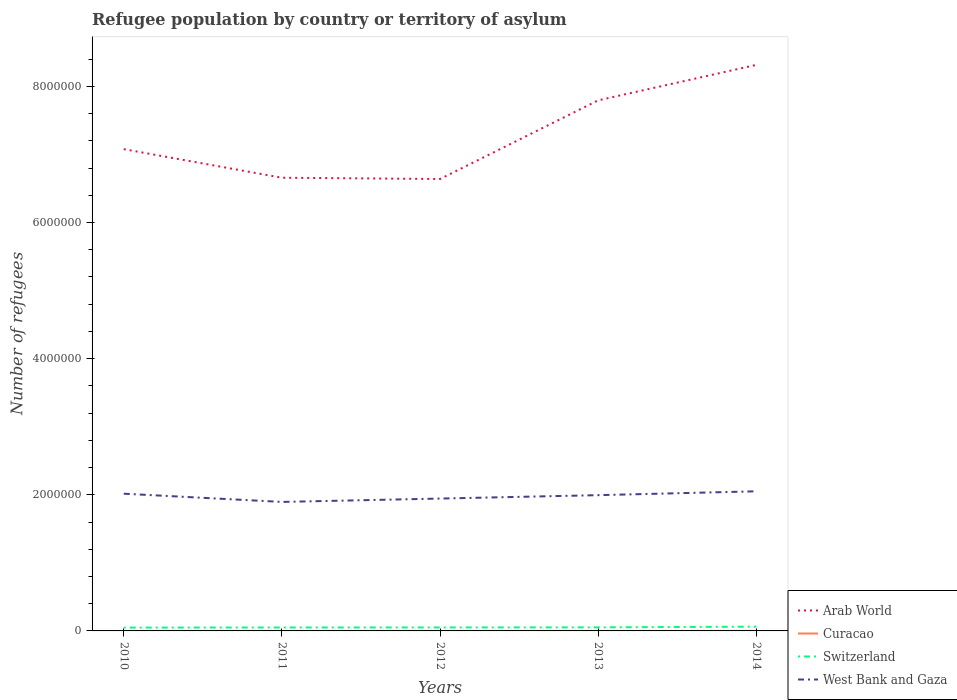How many different coloured lines are there?
Provide a short and direct response. 4. Does the line corresponding to Curacao intersect with the line corresponding to Arab World?
Your answer should be compact. No. Is the number of lines equal to the number of legend labels?
Offer a terse response. Yes. Across all years, what is the maximum number of refugees in Curacao?
Give a very brief answer. 6. What is the difference between the highest and the second highest number of refugees in West Bank and Gaza?
Provide a short and direct response. 1.56e+05. What is the difference between the highest and the lowest number of refugees in Switzerland?
Provide a succinct answer. 1. How many lines are there?
Give a very brief answer. 4. Does the graph contain any zero values?
Give a very brief answer. No. How many legend labels are there?
Your answer should be compact. 4. How are the legend labels stacked?
Ensure brevity in your answer.  Vertical. What is the title of the graph?
Offer a terse response. Refugee population by country or territory of asylum. Does "Turks and Caicos Islands" appear as one of the legend labels in the graph?
Give a very brief answer. No. What is the label or title of the Y-axis?
Ensure brevity in your answer.  Number of refugees. What is the Number of refugees in Arab World in 2010?
Make the answer very short. 7.08e+06. What is the Number of refugees of Switzerland in 2010?
Offer a terse response. 4.88e+04. What is the Number of refugees in West Bank and Gaza in 2010?
Offer a very short reply. 2.02e+06. What is the Number of refugees of Arab World in 2011?
Your response must be concise. 6.66e+06. What is the Number of refugees in Switzerland in 2011?
Keep it short and to the point. 5.04e+04. What is the Number of refugees in West Bank and Gaza in 2011?
Your answer should be very brief. 1.90e+06. What is the Number of refugees in Arab World in 2012?
Make the answer very short. 6.64e+06. What is the Number of refugees in Switzerland in 2012?
Offer a very short reply. 5.07e+04. What is the Number of refugees of West Bank and Gaza in 2012?
Offer a terse response. 1.94e+06. What is the Number of refugees of Arab World in 2013?
Provide a succinct answer. 7.79e+06. What is the Number of refugees in Switzerland in 2013?
Ensure brevity in your answer.  5.25e+04. What is the Number of refugees of West Bank and Gaza in 2013?
Keep it short and to the point. 1.99e+06. What is the Number of refugees in Arab World in 2014?
Offer a terse response. 8.32e+06. What is the Number of refugees in Curacao in 2014?
Provide a succinct answer. 37. What is the Number of refugees of Switzerland in 2014?
Your response must be concise. 6.26e+04. What is the Number of refugees of West Bank and Gaza in 2014?
Make the answer very short. 2.05e+06. Across all years, what is the maximum Number of refugees in Arab World?
Your answer should be very brief. 8.32e+06. Across all years, what is the maximum Number of refugees of Curacao?
Your answer should be compact. 37. Across all years, what is the maximum Number of refugees of Switzerland?
Keep it short and to the point. 6.26e+04. Across all years, what is the maximum Number of refugees in West Bank and Gaza?
Offer a terse response. 2.05e+06. Across all years, what is the minimum Number of refugees in Arab World?
Offer a terse response. 6.64e+06. Across all years, what is the minimum Number of refugees in Switzerland?
Give a very brief answer. 4.88e+04. Across all years, what is the minimum Number of refugees in West Bank and Gaza?
Provide a short and direct response. 1.90e+06. What is the total Number of refugees of Arab World in the graph?
Provide a short and direct response. 3.65e+07. What is the total Number of refugees in Curacao in the graph?
Your response must be concise. 79. What is the total Number of refugees in Switzerland in the graph?
Your response must be concise. 2.65e+05. What is the total Number of refugees in West Bank and Gaza in the graph?
Provide a short and direct response. 9.90e+06. What is the difference between the Number of refugees in Arab World in 2010 and that in 2011?
Your response must be concise. 4.20e+05. What is the difference between the Number of refugees of Switzerland in 2010 and that in 2011?
Your answer should be very brief. -1603. What is the difference between the Number of refugees in West Bank and Gaza in 2010 and that in 2011?
Make the answer very short. 1.21e+05. What is the difference between the Number of refugees in Arab World in 2010 and that in 2012?
Your answer should be very brief. 4.39e+05. What is the difference between the Number of refugees in Switzerland in 2010 and that in 2012?
Make the answer very short. -1934. What is the difference between the Number of refugees of West Bank and Gaza in 2010 and that in 2012?
Offer a very short reply. 7.13e+04. What is the difference between the Number of refugees in Arab World in 2010 and that in 2013?
Your response must be concise. -7.17e+05. What is the difference between the Number of refugees of Switzerland in 2010 and that in 2013?
Your answer should be compact. -3651. What is the difference between the Number of refugees in West Bank and Gaza in 2010 and that in 2013?
Make the answer very short. 2.14e+04. What is the difference between the Number of refugees in Arab World in 2010 and that in 2014?
Give a very brief answer. -1.24e+06. What is the difference between the Number of refugees in Switzerland in 2010 and that in 2014?
Your answer should be compact. -1.38e+04. What is the difference between the Number of refugees in West Bank and Gaza in 2010 and that in 2014?
Give a very brief answer. -3.52e+04. What is the difference between the Number of refugees in Arab World in 2011 and that in 2012?
Provide a succinct answer. 1.87e+04. What is the difference between the Number of refugees in Switzerland in 2011 and that in 2012?
Ensure brevity in your answer.  -331. What is the difference between the Number of refugees of West Bank and Gaza in 2011 and that in 2012?
Your answer should be very brief. -4.95e+04. What is the difference between the Number of refugees of Arab World in 2011 and that in 2013?
Keep it short and to the point. -1.14e+06. What is the difference between the Number of refugees of Switzerland in 2011 and that in 2013?
Offer a very short reply. -2048. What is the difference between the Number of refugees in West Bank and Gaza in 2011 and that in 2013?
Your answer should be compact. -9.94e+04. What is the difference between the Number of refugees in Arab World in 2011 and that in 2014?
Your answer should be compact. -1.66e+06. What is the difference between the Number of refugees in Curacao in 2011 and that in 2014?
Provide a succinct answer. -31. What is the difference between the Number of refugees of Switzerland in 2011 and that in 2014?
Offer a terse response. -1.22e+04. What is the difference between the Number of refugees of West Bank and Gaza in 2011 and that in 2014?
Your answer should be very brief. -1.56e+05. What is the difference between the Number of refugees in Arab World in 2012 and that in 2013?
Provide a succinct answer. -1.16e+06. What is the difference between the Number of refugees of Switzerland in 2012 and that in 2013?
Offer a very short reply. -1717. What is the difference between the Number of refugees of West Bank and Gaza in 2012 and that in 2013?
Offer a very short reply. -4.99e+04. What is the difference between the Number of refugees in Arab World in 2012 and that in 2014?
Offer a terse response. -1.68e+06. What is the difference between the Number of refugees of Curacao in 2012 and that in 2014?
Ensure brevity in your answer.  -23. What is the difference between the Number of refugees of Switzerland in 2012 and that in 2014?
Provide a short and direct response. -1.19e+04. What is the difference between the Number of refugees in West Bank and Gaza in 2012 and that in 2014?
Provide a succinct answer. -1.07e+05. What is the difference between the Number of refugees of Arab World in 2013 and that in 2014?
Ensure brevity in your answer.  -5.21e+05. What is the difference between the Number of refugees of Switzerland in 2013 and that in 2014?
Offer a very short reply. -1.02e+04. What is the difference between the Number of refugees in West Bank and Gaza in 2013 and that in 2014?
Offer a terse response. -5.66e+04. What is the difference between the Number of refugees in Arab World in 2010 and the Number of refugees in Curacao in 2011?
Provide a succinct answer. 7.08e+06. What is the difference between the Number of refugees in Arab World in 2010 and the Number of refugees in Switzerland in 2011?
Give a very brief answer. 7.03e+06. What is the difference between the Number of refugees of Arab World in 2010 and the Number of refugees of West Bank and Gaza in 2011?
Offer a terse response. 5.18e+06. What is the difference between the Number of refugees in Curacao in 2010 and the Number of refugees in Switzerland in 2011?
Your response must be concise. -5.04e+04. What is the difference between the Number of refugees of Curacao in 2010 and the Number of refugees of West Bank and Gaza in 2011?
Give a very brief answer. -1.90e+06. What is the difference between the Number of refugees in Switzerland in 2010 and the Number of refugees in West Bank and Gaza in 2011?
Provide a short and direct response. -1.85e+06. What is the difference between the Number of refugees in Arab World in 2010 and the Number of refugees in Curacao in 2012?
Ensure brevity in your answer.  7.08e+06. What is the difference between the Number of refugees in Arab World in 2010 and the Number of refugees in Switzerland in 2012?
Provide a short and direct response. 7.03e+06. What is the difference between the Number of refugees in Arab World in 2010 and the Number of refugees in West Bank and Gaza in 2012?
Provide a succinct answer. 5.13e+06. What is the difference between the Number of refugees of Curacao in 2010 and the Number of refugees of Switzerland in 2012?
Your answer should be very brief. -5.07e+04. What is the difference between the Number of refugees of Curacao in 2010 and the Number of refugees of West Bank and Gaza in 2012?
Give a very brief answer. -1.94e+06. What is the difference between the Number of refugees of Switzerland in 2010 and the Number of refugees of West Bank and Gaza in 2012?
Offer a very short reply. -1.90e+06. What is the difference between the Number of refugees in Arab World in 2010 and the Number of refugees in Curacao in 2013?
Offer a terse response. 7.08e+06. What is the difference between the Number of refugees of Arab World in 2010 and the Number of refugees of Switzerland in 2013?
Offer a very short reply. 7.03e+06. What is the difference between the Number of refugees in Arab World in 2010 and the Number of refugees in West Bank and Gaza in 2013?
Provide a succinct answer. 5.08e+06. What is the difference between the Number of refugees in Curacao in 2010 and the Number of refugees in Switzerland in 2013?
Offer a terse response. -5.25e+04. What is the difference between the Number of refugees of Curacao in 2010 and the Number of refugees of West Bank and Gaza in 2013?
Give a very brief answer. -1.99e+06. What is the difference between the Number of refugees in Switzerland in 2010 and the Number of refugees in West Bank and Gaza in 2013?
Offer a terse response. -1.95e+06. What is the difference between the Number of refugees of Arab World in 2010 and the Number of refugees of Curacao in 2014?
Provide a succinct answer. 7.08e+06. What is the difference between the Number of refugees of Arab World in 2010 and the Number of refugees of Switzerland in 2014?
Keep it short and to the point. 7.01e+06. What is the difference between the Number of refugees in Arab World in 2010 and the Number of refugees in West Bank and Gaza in 2014?
Provide a succinct answer. 5.03e+06. What is the difference between the Number of refugees of Curacao in 2010 and the Number of refugees of Switzerland in 2014?
Your answer should be very brief. -6.26e+04. What is the difference between the Number of refugees in Curacao in 2010 and the Number of refugees in West Bank and Gaza in 2014?
Keep it short and to the point. -2.05e+06. What is the difference between the Number of refugees of Switzerland in 2010 and the Number of refugees of West Bank and Gaza in 2014?
Ensure brevity in your answer.  -2.00e+06. What is the difference between the Number of refugees in Arab World in 2011 and the Number of refugees in Curacao in 2012?
Provide a succinct answer. 6.66e+06. What is the difference between the Number of refugees of Arab World in 2011 and the Number of refugees of Switzerland in 2012?
Your answer should be very brief. 6.61e+06. What is the difference between the Number of refugees in Arab World in 2011 and the Number of refugees in West Bank and Gaza in 2012?
Provide a short and direct response. 4.71e+06. What is the difference between the Number of refugees in Curacao in 2011 and the Number of refugees in Switzerland in 2012?
Offer a very short reply. -5.07e+04. What is the difference between the Number of refugees of Curacao in 2011 and the Number of refugees of West Bank and Gaza in 2012?
Your response must be concise. -1.94e+06. What is the difference between the Number of refugees in Switzerland in 2011 and the Number of refugees in West Bank and Gaza in 2012?
Keep it short and to the point. -1.89e+06. What is the difference between the Number of refugees of Arab World in 2011 and the Number of refugees of Curacao in 2013?
Provide a short and direct response. 6.66e+06. What is the difference between the Number of refugees in Arab World in 2011 and the Number of refugees in Switzerland in 2013?
Offer a terse response. 6.61e+06. What is the difference between the Number of refugees in Arab World in 2011 and the Number of refugees in West Bank and Gaza in 2013?
Offer a terse response. 4.66e+06. What is the difference between the Number of refugees in Curacao in 2011 and the Number of refugees in Switzerland in 2013?
Give a very brief answer. -5.25e+04. What is the difference between the Number of refugees of Curacao in 2011 and the Number of refugees of West Bank and Gaza in 2013?
Your answer should be very brief. -1.99e+06. What is the difference between the Number of refugees of Switzerland in 2011 and the Number of refugees of West Bank and Gaza in 2013?
Make the answer very short. -1.94e+06. What is the difference between the Number of refugees of Arab World in 2011 and the Number of refugees of Curacao in 2014?
Ensure brevity in your answer.  6.66e+06. What is the difference between the Number of refugees of Arab World in 2011 and the Number of refugees of Switzerland in 2014?
Your answer should be very brief. 6.60e+06. What is the difference between the Number of refugees of Arab World in 2011 and the Number of refugees of West Bank and Gaza in 2014?
Keep it short and to the point. 4.61e+06. What is the difference between the Number of refugees in Curacao in 2011 and the Number of refugees in Switzerland in 2014?
Offer a very short reply. -6.26e+04. What is the difference between the Number of refugees of Curacao in 2011 and the Number of refugees of West Bank and Gaza in 2014?
Provide a short and direct response. -2.05e+06. What is the difference between the Number of refugees in Switzerland in 2011 and the Number of refugees in West Bank and Gaza in 2014?
Offer a very short reply. -2.00e+06. What is the difference between the Number of refugees in Arab World in 2012 and the Number of refugees in Curacao in 2013?
Keep it short and to the point. 6.64e+06. What is the difference between the Number of refugees of Arab World in 2012 and the Number of refugees of Switzerland in 2013?
Keep it short and to the point. 6.59e+06. What is the difference between the Number of refugees in Arab World in 2012 and the Number of refugees in West Bank and Gaza in 2013?
Offer a very short reply. 4.64e+06. What is the difference between the Number of refugees of Curacao in 2012 and the Number of refugees of Switzerland in 2013?
Offer a terse response. -5.24e+04. What is the difference between the Number of refugees of Curacao in 2012 and the Number of refugees of West Bank and Gaza in 2013?
Your answer should be compact. -1.99e+06. What is the difference between the Number of refugees in Switzerland in 2012 and the Number of refugees in West Bank and Gaza in 2013?
Ensure brevity in your answer.  -1.94e+06. What is the difference between the Number of refugees in Arab World in 2012 and the Number of refugees in Curacao in 2014?
Your answer should be compact. 6.64e+06. What is the difference between the Number of refugees in Arab World in 2012 and the Number of refugees in Switzerland in 2014?
Ensure brevity in your answer.  6.58e+06. What is the difference between the Number of refugees of Arab World in 2012 and the Number of refugees of West Bank and Gaza in 2014?
Your answer should be very brief. 4.59e+06. What is the difference between the Number of refugees of Curacao in 2012 and the Number of refugees of Switzerland in 2014?
Offer a very short reply. -6.26e+04. What is the difference between the Number of refugees in Curacao in 2012 and the Number of refugees in West Bank and Gaza in 2014?
Provide a short and direct response. -2.05e+06. What is the difference between the Number of refugees in Switzerland in 2012 and the Number of refugees in West Bank and Gaza in 2014?
Ensure brevity in your answer.  -2.00e+06. What is the difference between the Number of refugees of Arab World in 2013 and the Number of refugees of Curacao in 2014?
Offer a terse response. 7.79e+06. What is the difference between the Number of refugees of Arab World in 2013 and the Number of refugees of Switzerland in 2014?
Keep it short and to the point. 7.73e+06. What is the difference between the Number of refugees of Arab World in 2013 and the Number of refugees of West Bank and Gaza in 2014?
Give a very brief answer. 5.74e+06. What is the difference between the Number of refugees in Curacao in 2013 and the Number of refugees in Switzerland in 2014?
Your answer should be very brief. -6.26e+04. What is the difference between the Number of refugees in Curacao in 2013 and the Number of refugees in West Bank and Gaza in 2014?
Provide a succinct answer. -2.05e+06. What is the difference between the Number of refugees in Switzerland in 2013 and the Number of refugees in West Bank and Gaza in 2014?
Make the answer very short. -2.00e+06. What is the average Number of refugees of Arab World per year?
Provide a succinct answer. 7.30e+06. What is the average Number of refugees in Curacao per year?
Offer a terse response. 15.8. What is the average Number of refugees of Switzerland per year?
Provide a short and direct response. 5.30e+04. What is the average Number of refugees of West Bank and Gaza per year?
Your response must be concise. 1.98e+06. In the year 2010, what is the difference between the Number of refugees of Arab World and Number of refugees of Curacao?
Provide a short and direct response. 7.08e+06. In the year 2010, what is the difference between the Number of refugees of Arab World and Number of refugees of Switzerland?
Provide a short and direct response. 7.03e+06. In the year 2010, what is the difference between the Number of refugees of Arab World and Number of refugees of West Bank and Gaza?
Provide a short and direct response. 5.06e+06. In the year 2010, what is the difference between the Number of refugees of Curacao and Number of refugees of Switzerland?
Give a very brief answer. -4.88e+04. In the year 2010, what is the difference between the Number of refugees of Curacao and Number of refugees of West Bank and Gaza?
Your response must be concise. -2.02e+06. In the year 2010, what is the difference between the Number of refugees in Switzerland and Number of refugees in West Bank and Gaza?
Your answer should be compact. -1.97e+06. In the year 2011, what is the difference between the Number of refugees of Arab World and Number of refugees of Curacao?
Make the answer very short. 6.66e+06. In the year 2011, what is the difference between the Number of refugees in Arab World and Number of refugees in Switzerland?
Offer a very short reply. 6.61e+06. In the year 2011, what is the difference between the Number of refugees in Arab World and Number of refugees in West Bank and Gaza?
Your response must be concise. 4.76e+06. In the year 2011, what is the difference between the Number of refugees in Curacao and Number of refugees in Switzerland?
Provide a succinct answer. -5.04e+04. In the year 2011, what is the difference between the Number of refugees in Curacao and Number of refugees in West Bank and Gaza?
Your answer should be very brief. -1.90e+06. In the year 2011, what is the difference between the Number of refugees in Switzerland and Number of refugees in West Bank and Gaza?
Ensure brevity in your answer.  -1.84e+06. In the year 2012, what is the difference between the Number of refugees of Arab World and Number of refugees of Curacao?
Offer a terse response. 6.64e+06. In the year 2012, what is the difference between the Number of refugees in Arab World and Number of refugees in Switzerland?
Offer a terse response. 6.59e+06. In the year 2012, what is the difference between the Number of refugees in Arab World and Number of refugees in West Bank and Gaza?
Offer a terse response. 4.69e+06. In the year 2012, what is the difference between the Number of refugees in Curacao and Number of refugees in Switzerland?
Provide a short and direct response. -5.07e+04. In the year 2012, what is the difference between the Number of refugees in Curacao and Number of refugees in West Bank and Gaza?
Give a very brief answer. -1.94e+06. In the year 2012, what is the difference between the Number of refugees of Switzerland and Number of refugees of West Bank and Gaza?
Your response must be concise. -1.89e+06. In the year 2013, what is the difference between the Number of refugees in Arab World and Number of refugees in Curacao?
Give a very brief answer. 7.79e+06. In the year 2013, what is the difference between the Number of refugees in Arab World and Number of refugees in Switzerland?
Offer a terse response. 7.74e+06. In the year 2013, what is the difference between the Number of refugees of Arab World and Number of refugees of West Bank and Gaza?
Provide a short and direct response. 5.80e+06. In the year 2013, what is the difference between the Number of refugees of Curacao and Number of refugees of Switzerland?
Your answer should be very brief. -5.24e+04. In the year 2013, what is the difference between the Number of refugees of Curacao and Number of refugees of West Bank and Gaza?
Provide a succinct answer. -1.99e+06. In the year 2013, what is the difference between the Number of refugees of Switzerland and Number of refugees of West Bank and Gaza?
Provide a short and direct response. -1.94e+06. In the year 2014, what is the difference between the Number of refugees of Arab World and Number of refugees of Curacao?
Your answer should be very brief. 8.32e+06. In the year 2014, what is the difference between the Number of refugees of Arab World and Number of refugees of Switzerland?
Your answer should be compact. 8.25e+06. In the year 2014, what is the difference between the Number of refugees of Arab World and Number of refugees of West Bank and Gaza?
Keep it short and to the point. 6.26e+06. In the year 2014, what is the difference between the Number of refugees in Curacao and Number of refugees in Switzerland?
Keep it short and to the point. -6.26e+04. In the year 2014, what is the difference between the Number of refugees in Curacao and Number of refugees in West Bank and Gaza?
Your answer should be very brief. -2.05e+06. In the year 2014, what is the difference between the Number of refugees of Switzerland and Number of refugees of West Bank and Gaza?
Your response must be concise. -1.99e+06. What is the ratio of the Number of refugees in Arab World in 2010 to that in 2011?
Ensure brevity in your answer.  1.06. What is the ratio of the Number of refugees in Curacao in 2010 to that in 2011?
Your answer should be very brief. 1.17. What is the ratio of the Number of refugees of Switzerland in 2010 to that in 2011?
Offer a terse response. 0.97. What is the ratio of the Number of refugees of West Bank and Gaza in 2010 to that in 2011?
Offer a terse response. 1.06. What is the ratio of the Number of refugees of Arab World in 2010 to that in 2012?
Give a very brief answer. 1.07. What is the ratio of the Number of refugees in Switzerland in 2010 to that in 2012?
Offer a very short reply. 0.96. What is the ratio of the Number of refugees of West Bank and Gaza in 2010 to that in 2012?
Your answer should be compact. 1.04. What is the ratio of the Number of refugees of Arab World in 2010 to that in 2013?
Your answer should be compact. 0.91. What is the ratio of the Number of refugees in Curacao in 2010 to that in 2013?
Your answer should be very brief. 0.47. What is the ratio of the Number of refugees in Switzerland in 2010 to that in 2013?
Your answer should be very brief. 0.93. What is the ratio of the Number of refugees in West Bank and Gaza in 2010 to that in 2013?
Your answer should be compact. 1.01. What is the ratio of the Number of refugees in Arab World in 2010 to that in 2014?
Provide a short and direct response. 0.85. What is the ratio of the Number of refugees of Curacao in 2010 to that in 2014?
Make the answer very short. 0.19. What is the ratio of the Number of refugees of Switzerland in 2010 to that in 2014?
Offer a very short reply. 0.78. What is the ratio of the Number of refugees in West Bank and Gaza in 2010 to that in 2014?
Provide a succinct answer. 0.98. What is the ratio of the Number of refugees of Arab World in 2011 to that in 2012?
Offer a terse response. 1. What is the ratio of the Number of refugees in Curacao in 2011 to that in 2012?
Offer a very short reply. 0.43. What is the ratio of the Number of refugees in West Bank and Gaza in 2011 to that in 2012?
Keep it short and to the point. 0.97. What is the ratio of the Number of refugees of Arab World in 2011 to that in 2013?
Provide a short and direct response. 0.85. What is the ratio of the Number of refugees in West Bank and Gaza in 2011 to that in 2013?
Keep it short and to the point. 0.95. What is the ratio of the Number of refugees in Arab World in 2011 to that in 2014?
Offer a very short reply. 0.8. What is the ratio of the Number of refugees in Curacao in 2011 to that in 2014?
Your answer should be compact. 0.16. What is the ratio of the Number of refugees of Switzerland in 2011 to that in 2014?
Provide a short and direct response. 0.81. What is the ratio of the Number of refugees in West Bank and Gaza in 2011 to that in 2014?
Provide a short and direct response. 0.92. What is the ratio of the Number of refugees in Arab World in 2012 to that in 2013?
Keep it short and to the point. 0.85. What is the ratio of the Number of refugees in Switzerland in 2012 to that in 2013?
Keep it short and to the point. 0.97. What is the ratio of the Number of refugees in Arab World in 2012 to that in 2014?
Provide a short and direct response. 0.8. What is the ratio of the Number of refugees in Curacao in 2012 to that in 2014?
Make the answer very short. 0.38. What is the ratio of the Number of refugees of Switzerland in 2012 to that in 2014?
Provide a succinct answer. 0.81. What is the ratio of the Number of refugees of West Bank and Gaza in 2012 to that in 2014?
Your response must be concise. 0.95. What is the ratio of the Number of refugees of Arab World in 2013 to that in 2014?
Your answer should be compact. 0.94. What is the ratio of the Number of refugees of Curacao in 2013 to that in 2014?
Offer a very short reply. 0.41. What is the ratio of the Number of refugees of Switzerland in 2013 to that in 2014?
Offer a terse response. 0.84. What is the ratio of the Number of refugees in West Bank and Gaza in 2013 to that in 2014?
Ensure brevity in your answer.  0.97. What is the difference between the highest and the second highest Number of refugees in Arab World?
Your answer should be compact. 5.21e+05. What is the difference between the highest and the second highest Number of refugees in Switzerland?
Your answer should be very brief. 1.02e+04. What is the difference between the highest and the second highest Number of refugees in West Bank and Gaza?
Offer a terse response. 3.52e+04. What is the difference between the highest and the lowest Number of refugees in Arab World?
Ensure brevity in your answer.  1.68e+06. What is the difference between the highest and the lowest Number of refugees in Curacao?
Offer a very short reply. 31. What is the difference between the highest and the lowest Number of refugees of Switzerland?
Keep it short and to the point. 1.38e+04. What is the difference between the highest and the lowest Number of refugees of West Bank and Gaza?
Ensure brevity in your answer.  1.56e+05. 